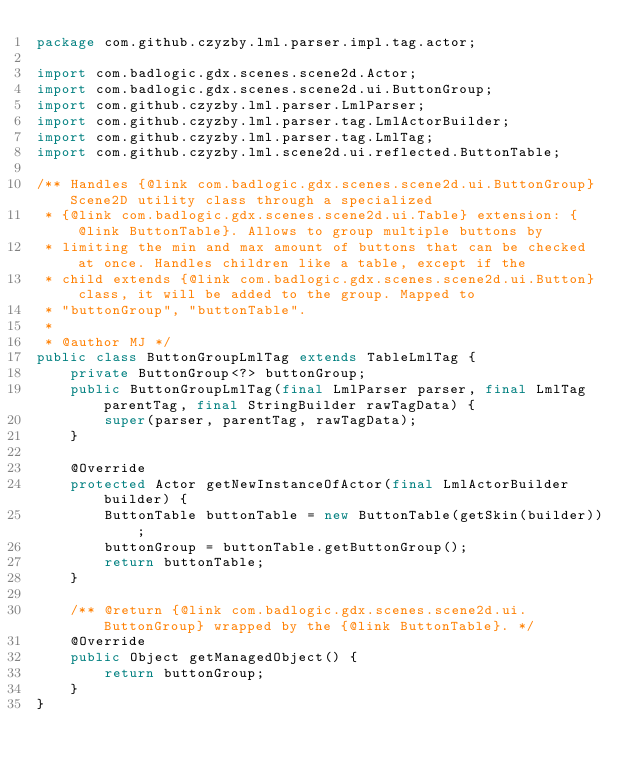<code> <loc_0><loc_0><loc_500><loc_500><_Java_>package com.github.czyzby.lml.parser.impl.tag.actor;

import com.badlogic.gdx.scenes.scene2d.Actor;
import com.badlogic.gdx.scenes.scene2d.ui.ButtonGroup;
import com.github.czyzby.lml.parser.LmlParser;
import com.github.czyzby.lml.parser.tag.LmlActorBuilder;
import com.github.czyzby.lml.parser.tag.LmlTag;
import com.github.czyzby.lml.scene2d.ui.reflected.ButtonTable;

/** Handles {@link com.badlogic.gdx.scenes.scene2d.ui.ButtonGroup} Scene2D utility class through a specialized
 * {@link com.badlogic.gdx.scenes.scene2d.ui.Table} extension: {@link ButtonTable}. Allows to group multiple buttons by
 * limiting the min and max amount of buttons that can be checked at once. Handles children like a table, except if the
 * child extends {@link com.badlogic.gdx.scenes.scene2d.ui.Button} class, it will be added to the group. Mapped to
 * "buttonGroup", "buttonTable".
 *
 * @author MJ */
public class ButtonGroupLmlTag extends TableLmlTag {
    private ButtonGroup<?> buttonGroup;
    public ButtonGroupLmlTag(final LmlParser parser, final LmlTag parentTag, final StringBuilder rawTagData) {
        super(parser, parentTag, rawTagData);
    }

    @Override
    protected Actor getNewInstanceOfActor(final LmlActorBuilder builder) {
        ButtonTable buttonTable = new ButtonTable(getSkin(builder));
        buttonGroup = buttonTable.getButtonGroup();
        return buttonTable;
    }

    /** @return {@link com.badlogic.gdx.scenes.scene2d.ui.ButtonGroup} wrapped by the {@link ButtonTable}. */
    @Override
    public Object getManagedObject() {
        return buttonGroup;
    }
}
</code> 